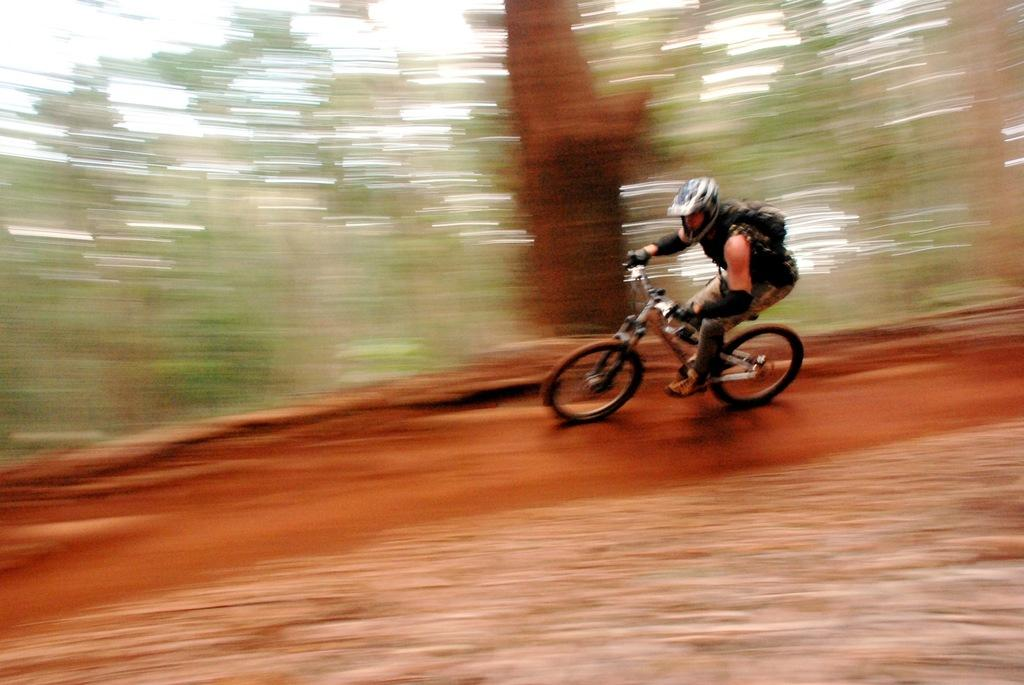What is the main subject of the image? There is a person in the image. What is the person doing in the image? The person is riding a bicycle. What is the position of the bicycle in the image? The bicycle is on the ground. What can be seen in the background of the image? There are trees in the background of the image. Can you see the person kissing someone in the image? There is no indication of a kiss or another person in the image; it only shows a person riding a bicycle. 